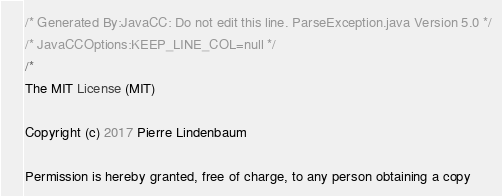<code> <loc_0><loc_0><loc_500><loc_500><_Java_>/* Generated By:JavaCC: Do not edit this line. ParseException.java Version 5.0 */
/* JavaCCOptions:KEEP_LINE_COL=null */
/*
The MIT License (MIT)

Copyright (c) 2017 Pierre Lindenbaum

Permission is hereby granted, free of charge, to any person obtaining a copy</code> 